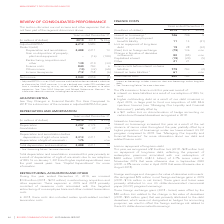According to Rogers Communications's financial document, What caused the increase in the total depreciation and amortization? result of depreciation of right-of-use assets due to our adoption of IFRS 16 on January 1, 2019 and higher capital expenditures over the past several years.. The document states: "nd amortization increased this year primarily as a result of depreciation of right-of-use assets due to our adoption of IFRS 16 on January 1, 2019 and..." Also, What was the depreciation in 2019? According to the financial document, 2,297 (in millions). The relevant text states: "Depreciation 2,297 2,174 6 Amortization 16 37 (57)..." Also, What was the Depreciation of right-of-use assets in 2019? According to the financial document, 175 (in millions). The relevant text states: "313 2,211 5 Depreciation of right-of-use assets 1 175 – n/m..." Also, can you calculate: What was the increase / (decrease) in the Depreciation from 2018 to 2019? Based on the calculation: 2,297 - 2,174, the result is 123 (in millions). This is based on the information: "Depreciation 2,297 2,174 6 Amortization 16 37 (57) Depreciation 2,297 2,174 6 Amortization 16 37 (57)..." The key data points involved are: 2,174, 2,297. Also, can you calculate: What was the average amortization? To answer this question, I need to perform calculations using the financial data. The calculation is: (16 + 37) / 2, which equals 26.5 (in millions). This is based on the information: "Depreciation 2,297 2,174 6 Amortization 16 37 (57) Depreciation 2,297 2,174 6 Amortization 16 37 (57)..." The key data points involved are: 16, 37. Also, can you calculate: What was the increase / (decrease) in the Total depreciation and amortization from 2018 to 2019? Based on the calculation: 2,488 - 2,211, the result is 277 (in millions). This is based on the information: "Total depreciation and amortization 2,488 2,211 13 Total depreciation and amortization 2,488 2,211 13..." The key data points involved are: 2,211, 2,488. 